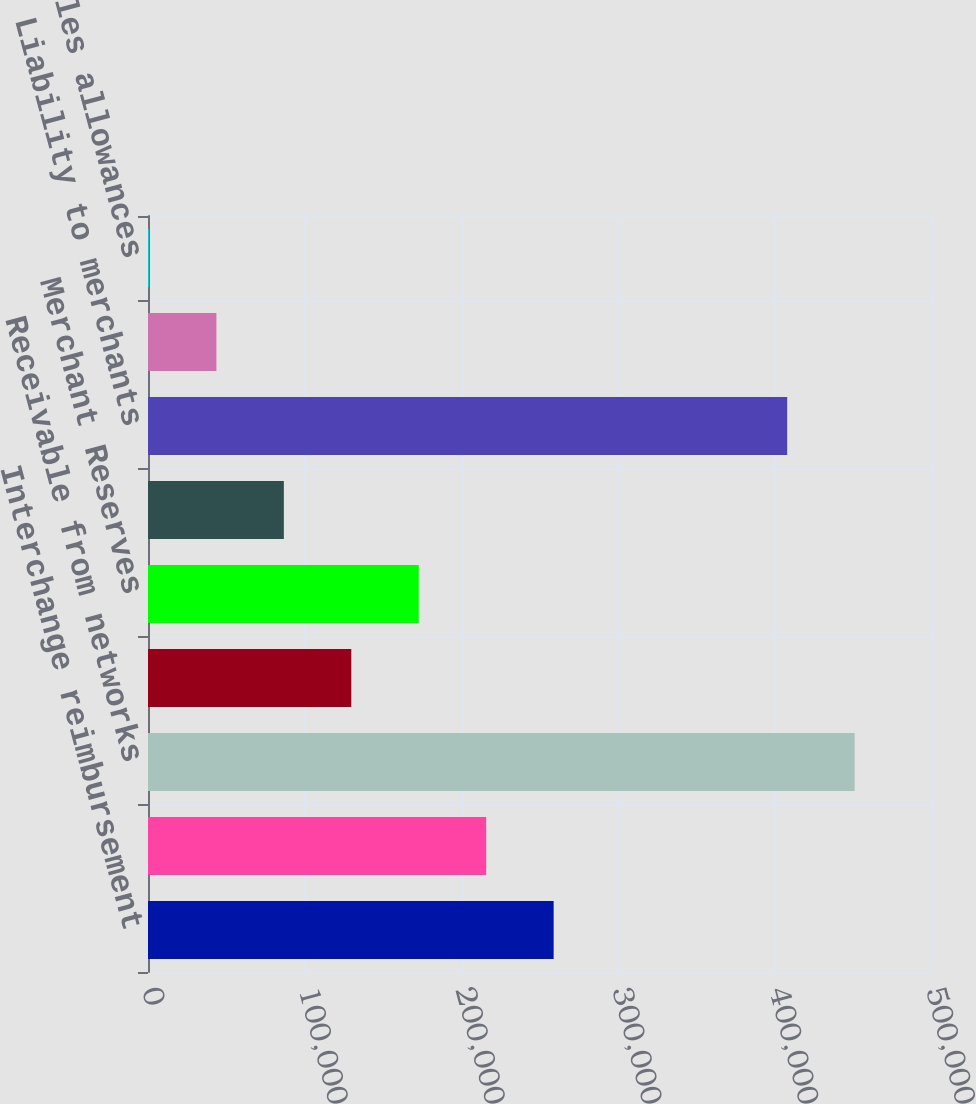Convert chart to OTSL. <chart><loc_0><loc_0><loc_500><loc_500><bar_chart><fcel>Interchange reimbursement<fcel>Receivable from Members<fcel>Receivable from networks<fcel>Exception items<fcel>Merchant Reserves<fcel>Liability to Members<fcel>Liability to merchants<fcel>Reserve for operating losses<fcel>Reserves for sales allowances<nl><fcel>258698<fcel>215682<fcel>450667<fcel>129650<fcel>172666<fcel>86633.4<fcel>407651<fcel>43617.2<fcel>601<nl></chart> 